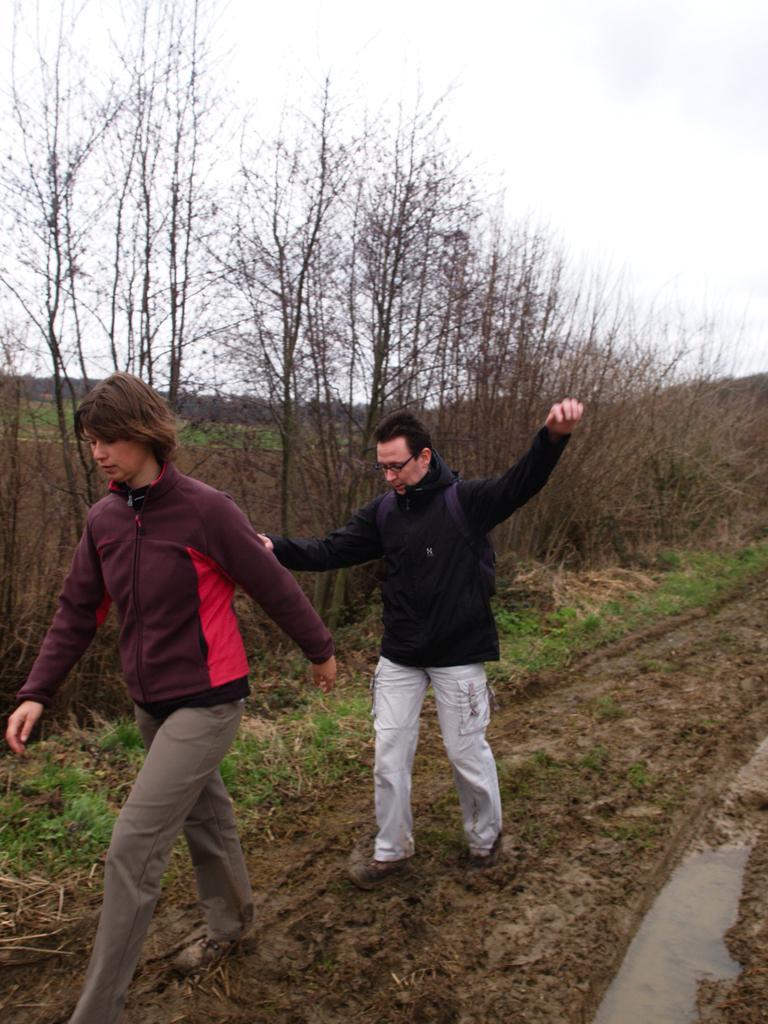Please provide a concise description of this image. In this image I can see two people walking and wearing different color dress. Back I can see few dry trees and grass. The sky is in blue and white color. 